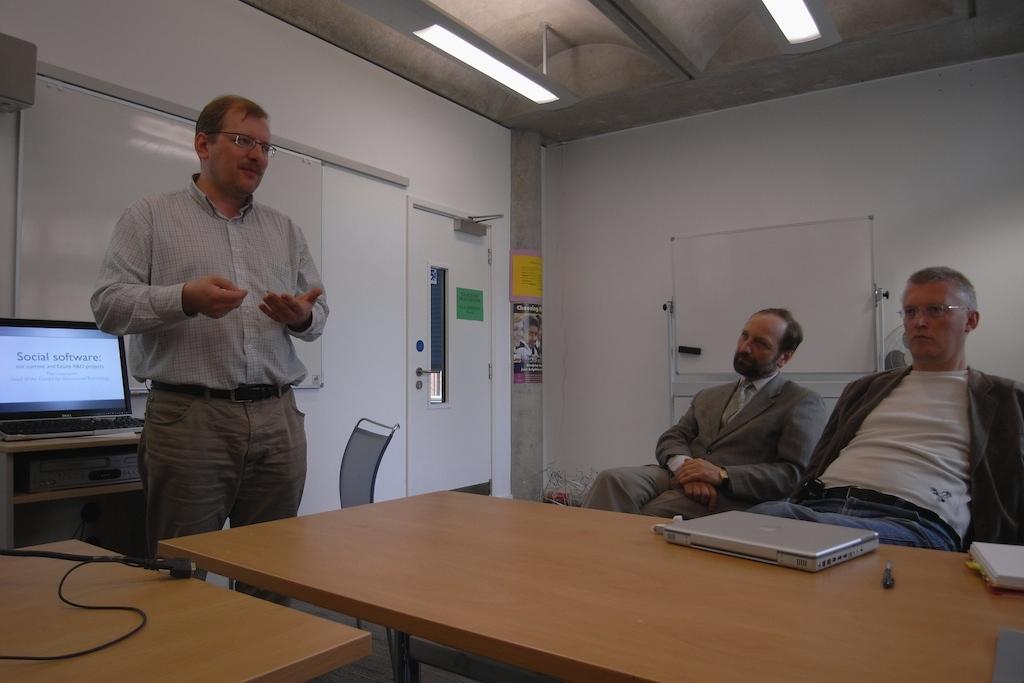Please provide a concise description of this image. On the left side of the image we can see a man standing. At the bottom there are tables and we can see laptops placed on the table. There are people sitting. We can see a computer placed on the stand. In the background there is a door and a board. At the top there are lights. 